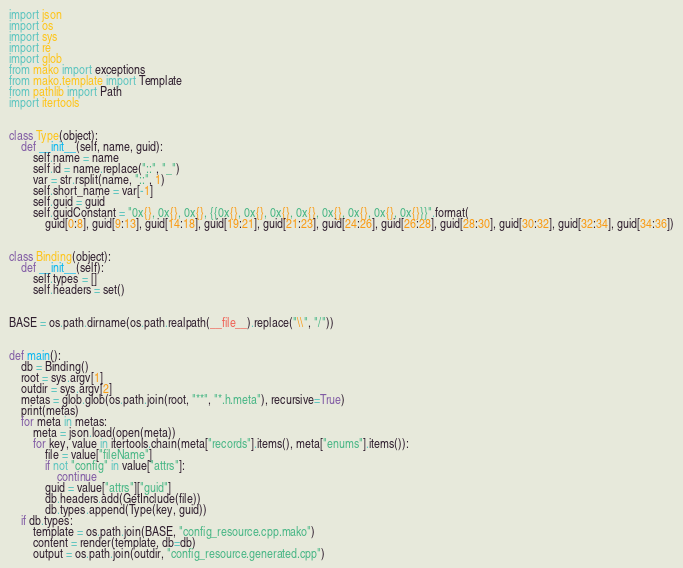Convert code to text. <code><loc_0><loc_0><loc_500><loc_500><_Python_>import json
import os
import sys
import re
import glob
from mako import exceptions
from mako.template import Template
from pathlib import Path
import itertools


class Type(object):
    def __init__(self, name, guid):
        self.name = name
        self.id = name.replace("::", "_")
        var = str.rsplit(name, "::", 1)
        self.short_name = var[-1]
        self.guid = guid
        self.guidConstant = "0x{}, 0x{}, 0x{}, {{0x{}, 0x{}, 0x{}, 0x{}, 0x{}, 0x{}, 0x{}, 0x{}}}".format(
            guid[0:8], guid[9:13], guid[14:18], guid[19:21], guid[21:23], guid[24:26], guid[26:28], guid[28:30], guid[30:32], guid[32:34], guid[34:36])


class Binding(object):
    def __init__(self):
        self.types = []
        self.headers = set()


BASE = os.path.dirname(os.path.realpath(__file__).replace("\\", "/"))


def main():
    db = Binding()
    root = sys.argv[1]
    outdir = sys.argv[2]
    metas = glob.glob(os.path.join(root, "**", "*.h.meta"), recursive=True)
    print(metas)
    for meta in metas:
        meta = json.load(open(meta))
        for key, value in itertools.chain(meta["records"].items(), meta["enums"].items()):
            file = value["fileName"]
            if not "config" in value["attrs"]:
                continue
            guid = value["attrs"]["guid"]
            db.headers.add(GetInclude(file))
            db.types.append(Type(key, guid))
    if db.types:
        template = os.path.join(BASE, "config_resource.cpp.mako")
        content = render(template, db=db)
        output = os.path.join(outdir, "config_resource.generated.cpp")</code> 